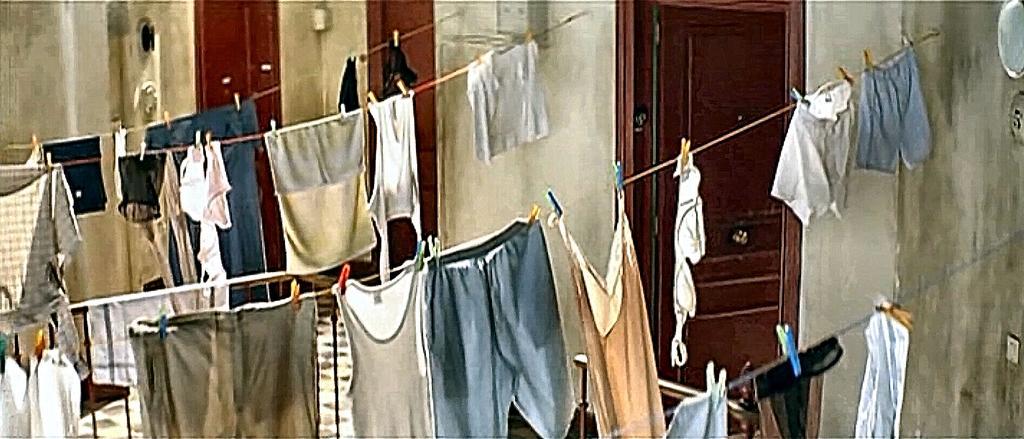Could you give a brief overview of what you see in this image? There are ropes tied to the wall and on the ropes a lot of clothes are are being dried and in the right side there are total three doors,in between the each door there is a wall. 